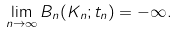Convert formula to latex. <formula><loc_0><loc_0><loc_500><loc_500>\lim _ { n \rightarrow \infty } B _ { n } ( K _ { n } ; t _ { n } ) = - \infty .</formula> 